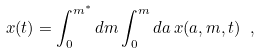<formula> <loc_0><loc_0><loc_500><loc_500>x ( t ) = \int _ { 0 } ^ { m ^ { * } } d m \int _ { 0 } ^ { m } d a \, x ( a , m , t ) \ ,</formula> 